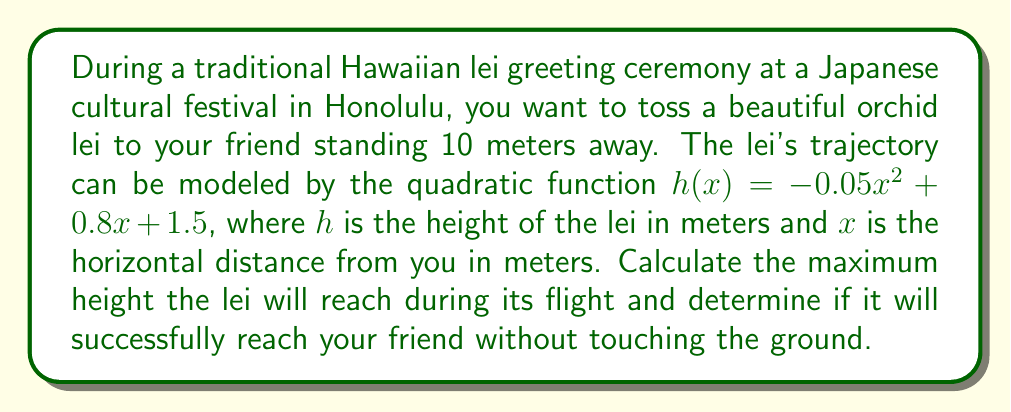Show me your answer to this math problem. To solve this problem, we need to follow these steps:

1. Find the vertex of the parabola to determine the maximum height:
   The quadratic function is in the form $h(x) = ax^2 + bx + c$, where $a = -0.05$, $b = 0.8$, and $c = 1.5$.
   
   The x-coordinate of the vertex is given by $x = -\frac{b}{2a}$:
   $$x = -\frac{0.8}{2(-0.05)} = 8\text{ meters}$$

   To find the maximum height, we substitute this x-value into the original function:
   $$h(8) = -0.05(8)^2 + 0.8(8) + 1.5$$
   $$= -0.05(64) + 6.4 + 1.5$$
   $$= -3.2 + 6.4 + 1.5$$
   $$= 4.7\text{ meters}$$

2. Determine if the lei will reach the friend:
   We need to calculate the height of the lei at $x = 10$ meters:
   $$h(10) = -0.05(10)^2 + 0.8(10) + 1.5$$
   $$= -5 + 8 + 1.5$$
   $$= 4.5\text{ meters}$$

   Since the height at 10 meters is positive (4.5 meters), the lei will successfully reach the friend without touching the ground.

[asy]
import graph;
size(200,150);
real f(real x) {return -0.05x^2 + 0.8x + 1.5;}
draw(graph(f,0,10),blue);
dot((8,4.7),red);
dot((10,4.5),green);
label("Max height",(8,4.7),N);
label("Friend",(10,4.5),E);
xaxis("Distance (m)",0,10,Arrow);
yaxis("Height (m)",0,5,Arrow);
[/asy]
Answer: The maximum height the lei will reach is 4.7 meters. The lei will successfully reach the friend at a height of 4.5 meters, without touching the ground. 